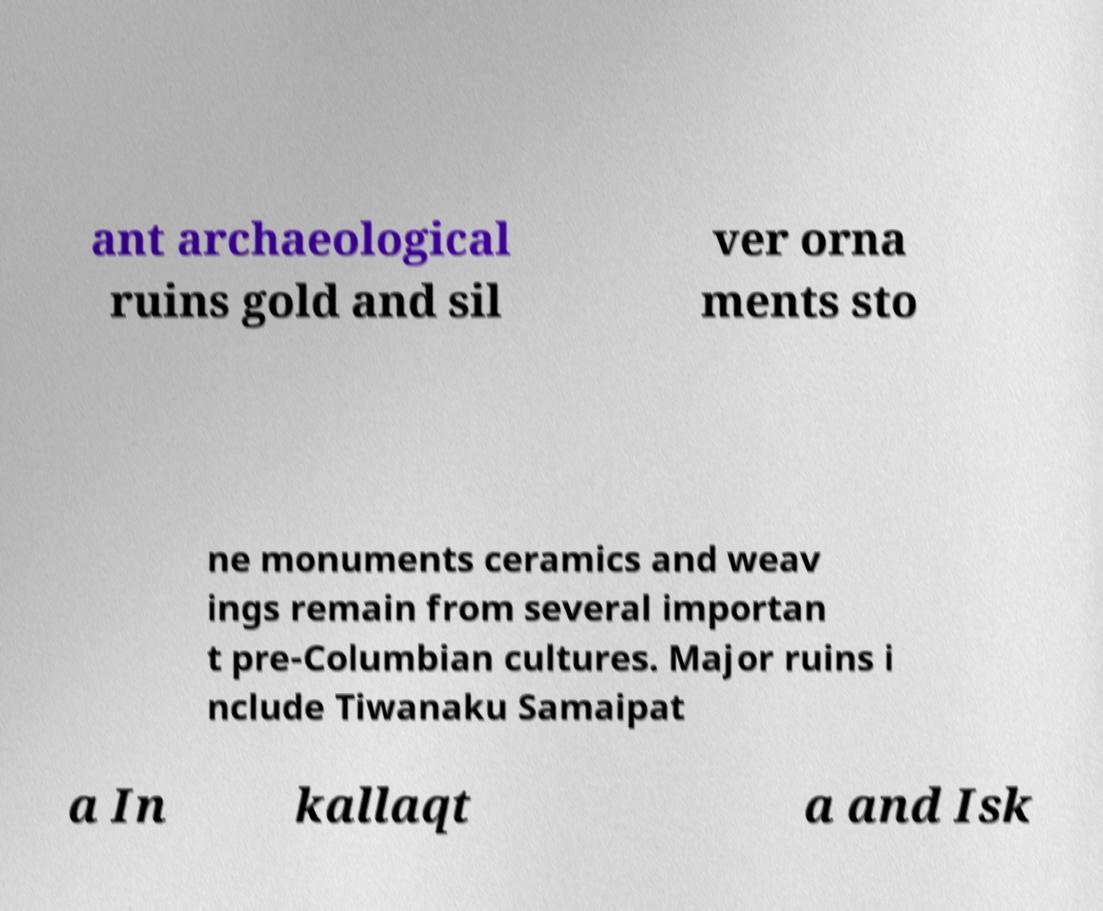Could you extract and type out the text from this image? ant archaeological ruins gold and sil ver orna ments sto ne monuments ceramics and weav ings remain from several importan t pre-Columbian cultures. Major ruins i nclude Tiwanaku Samaipat a In kallaqt a and Isk 